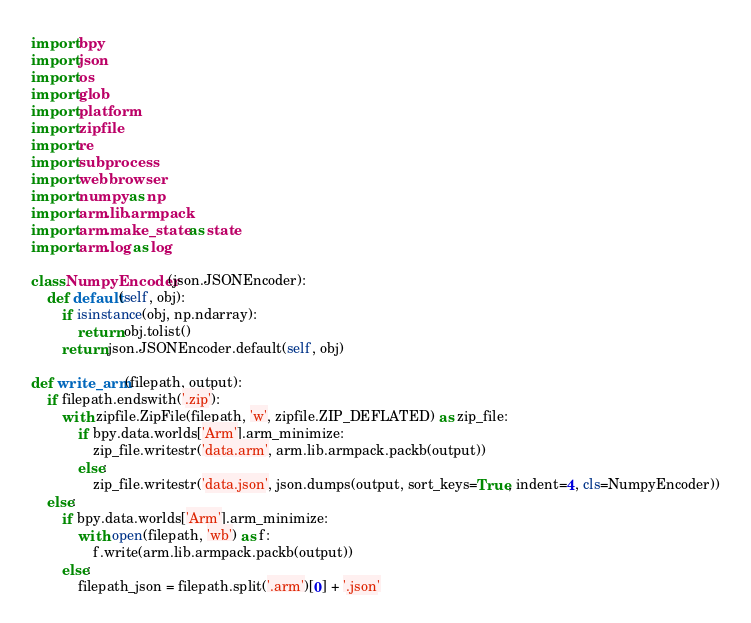Convert code to text. <code><loc_0><loc_0><loc_500><loc_500><_Python_>import bpy
import json
import os
import glob
import platform
import zipfile
import re
import subprocess
import webbrowser
import numpy as np
import arm.lib.armpack
import arm.make_state as state
import arm.log as log

class NumpyEncoder(json.JSONEncoder):
    def default(self, obj):
        if isinstance(obj, np.ndarray):
            return obj.tolist()
        return json.JSONEncoder.default(self, obj)

def write_arm(filepath, output):
    if filepath.endswith('.zip'):
        with zipfile.ZipFile(filepath, 'w', zipfile.ZIP_DEFLATED) as zip_file:
            if bpy.data.worlds['Arm'].arm_minimize:
                zip_file.writestr('data.arm', arm.lib.armpack.packb(output))
            else:
                zip_file.writestr('data.json', json.dumps(output, sort_keys=True, indent=4, cls=NumpyEncoder))
    else:
        if bpy.data.worlds['Arm'].arm_minimize:
            with open(filepath, 'wb') as f:
                f.write(arm.lib.armpack.packb(output))
        else:
            filepath_json = filepath.split('.arm')[0] + '.json'</code> 